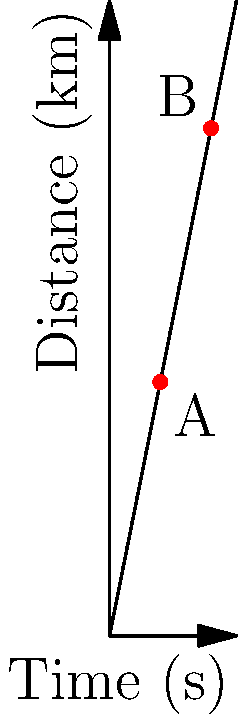Doraemon's time machine travels according to the distance-time graph shown above. Calculate the velocity of the time machine between points A and B. To calculate the velocity of Doraemon's time machine between points A and B, we need to use the formula for average velocity:

$$v = \frac{\Delta d}{\Delta t}$$

Where:
$v$ is velocity
$\Delta d$ is change in distance
$\Delta t$ is change in time

Step 1: Determine the coordinates of points A and B
A: (4 s, 20 km)
B: (8 s, 40 km)

Step 2: Calculate $\Delta d$ (change in distance)
$\Delta d = 40 \text{ km} - 20 \text{ km} = 20 \text{ km}$

Step 3: Calculate $\Delta t$ (change in time)
$\Delta t = 8 \text{ s} - 4 \text{ s} = 4 \text{ s}$

Step 4: Apply the velocity formula
$$v = \frac{\Delta d}{\Delta t} = \frac{20 \text{ km}}{4 \text{ s}} = 5 \text{ km/s}$$

Therefore, the velocity of Doraemon's time machine between points A and B is 5 km/s.
Answer: 5 km/s 